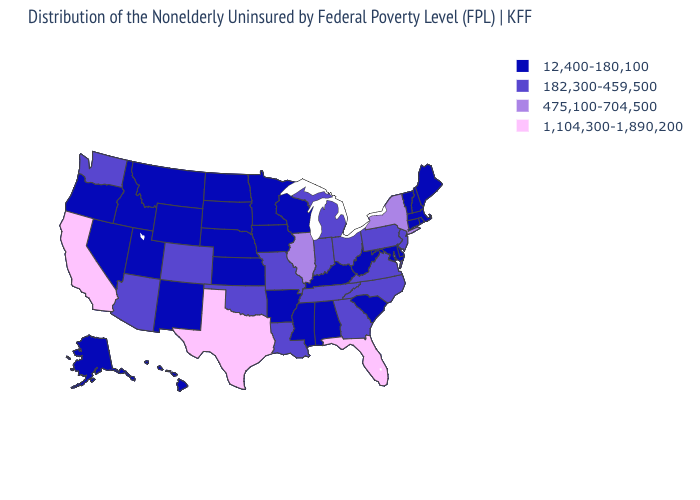Among the states that border Alabama , which have the highest value?
Write a very short answer. Florida. Does New Mexico have the same value as Montana?
Give a very brief answer. Yes. How many symbols are there in the legend?
Keep it brief. 4. Does Delaware have a lower value than Pennsylvania?
Write a very short answer. Yes. How many symbols are there in the legend?
Quick response, please. 4. Which states have the highest value in the USA?
Write a very short answer. California, Florida, Texas. Does Texas have the lowest value in the USA?
Short answer required. No. Name the states that have a value in the range 12,400-180,100?
Answer briefly. Alabama, Alaska, Arkansas, Connecticut, Delaware, Hawaii, Idaho, Iowa, Kansas, Kentucky, Maine, Maryland, Massachusetts, Minnesota, Mississippi, Montana, Nebraska, Nevada, New Hampshire, New Mexico, North Dakota, Oregon, Rhode Island, South Carolina, South Dakota, Utah, Vermont, West Virginia, Wisconsin, Wyoming. What is the value of Louisiana?
Concise answer only. 182,300-459,500. Name the states that have a value in the range 12,400-180,100?
Quick response, please. Alabama, Alaska, Arkansas, Connecticut, Delaware, Hawaii, Idaho, Iowa, Kansas, Kentucky, Maine, Maryland, Massachusetts, Minnesota, Mississippi, Montana, Nebraska, Nevada, New Hampshire, New Mexico, North Dakota, Oregon, Rhode Island, South Carolina, South Dakota, Utah, Vermont, West Virginia, Wisconsin, Wyoming. Name the states that have a value in the range 1,104,300-1,890,200?
Be succinct. California, Florida, Texas. What is the lowest value in the USA?
Write a very short answer. 12,400-180,100. Name the states that have a value in the range 475,100-704,500?
Concise answer only. Illinois, New York. Which states have the lowest value in the MidWest?
Be succinct. Iowa, Kansas, Minnesota, Nebraska, North Dakota, South Dakota, Wisconsin. 